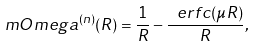<formula> <loc_0><loc_0><loc_500><loc_500>\ m O m e g a ^ { ( n ) } ( R ) = \frac { 1 } { R } - \frac { \ e r f c ( \mu R ) } { R } ,</formula> 